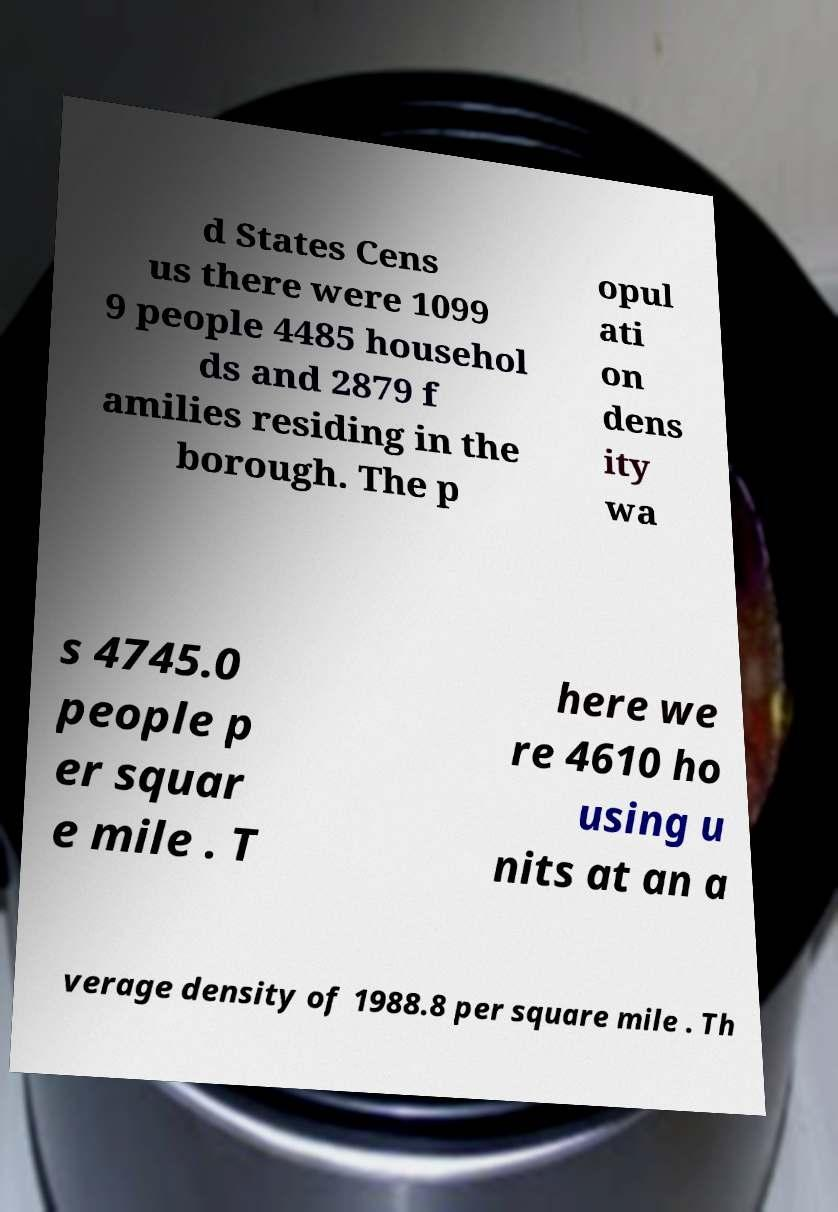Please identify and transcribe the text found in this image. d States Cens us there were 1099 9 people 4485 househol ds and 2879 f amilies residing in the borough. The p opul ati on dens ity wa s 4745.0 people p er squar e mile . T here we re 4610 ho using u nits at an a verage density of 1988.8 per square mile . Th 